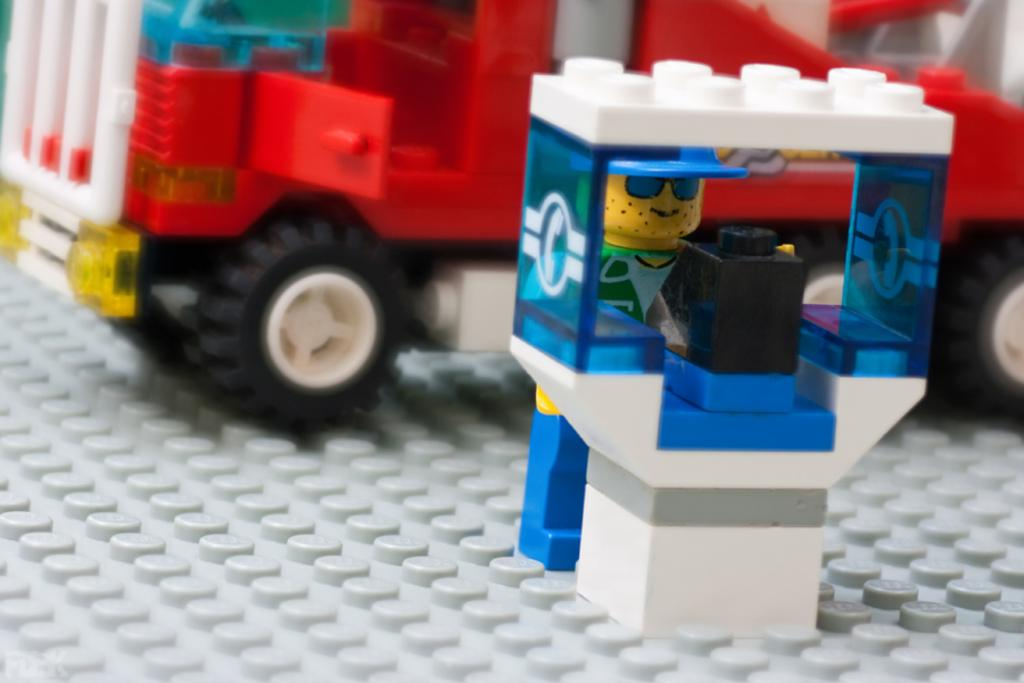What type of objects can be seen in the image? There are toys in the image. What type of park can be seen in the image? There is no park present in the image; it only features toys. What kind of road is visible in the image? There is no road present in the image; it only features toys. 